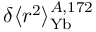<formula> <loc_0><loc_0><loc_500><loc_500>\delta \langle r ^ { 2 } \rangle _ { Y b } ^ { A , 1 7 2 }</formula> 